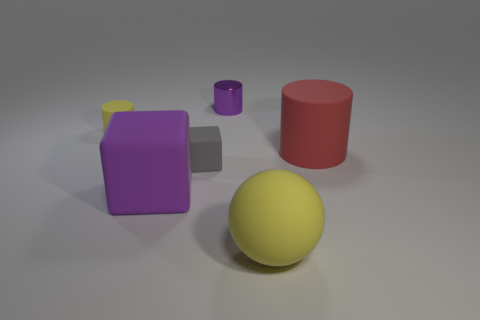There is a rubber object on the right side of the yellow object in front of the tiny cylinder in front of the shiny cylinder; what size is it?
Provide a short and direct response. Large. Are there any other things that have the same color as the tiny block?
Offer a terse response. No. What is the yellow object in front of the yellow matte object that is to the left of the yellow object in front of the yellow rubber cylinder made of?
Offer a terse response. Rubber. Does the tiny gray rubber object have the same shape as the big purple rubber object?
Provide a short and direct response. Yes. Are there any other things that have the same material as the tiny purple cylinder?
Make the answer very short. No. What number of rubber things are in front of the yellow matte cylinder and behind the gray rubber thing?
Offer a terse response. 1. There is a tiny rubber thing in front of the matte thing behind the large red cylinder; what is its color?
Ensure brevity in your answer.  Gray. Are there the same number of large yellow balls that are to the left of the purple metallic cylinder and blue things?
Your answer should be very brief. Yes. There is a purple thing that is in front of the cylinder that is right of the ball; what number of yellow rubber spheres are on the right side of it?
Keep it short and to the point. 1. What is the color of the large matte thing on the left side of the gray matte cube?
Offer a terse response. Purple. 